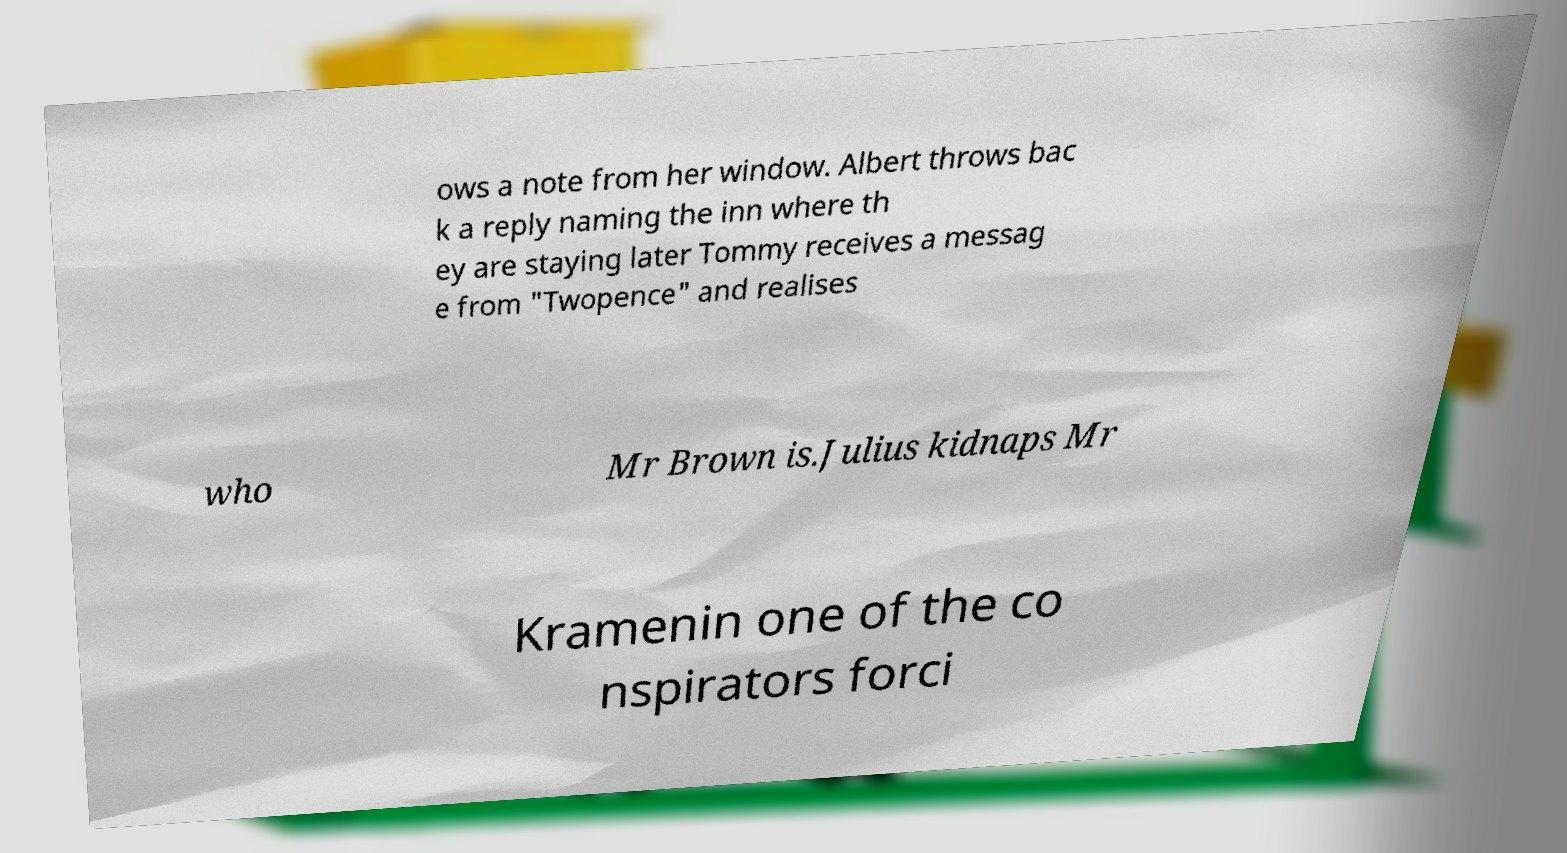Please identify and transcribe the text found in this image. ows a note from her window. Albert throws bac k a reply naming the inn where th ey are staying later Tommy receives a messag e from "Twopence" and realises who Mr Brown is.Julius kidnaps Mr Kramenin one of the co nspirators forci 